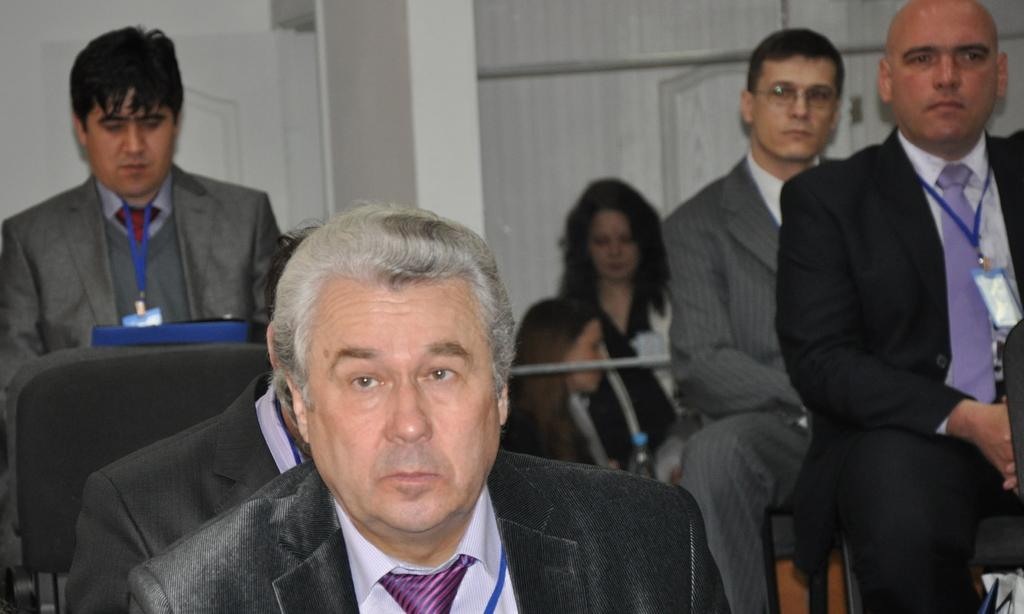What are the people in the image doing? The people in the image are sitting. What can be seen in the background of the image? There is a wall in the background of the image. What type of clothing are the people wearing? The people are wearing suits. What type of impulse can be seen affecting the people in the image? There is no mention of an impulse affecting the people in the image. Can you describe the wren that is perched on the wall in the background? There is no wren present in the image; only a wall is visible in the background. 